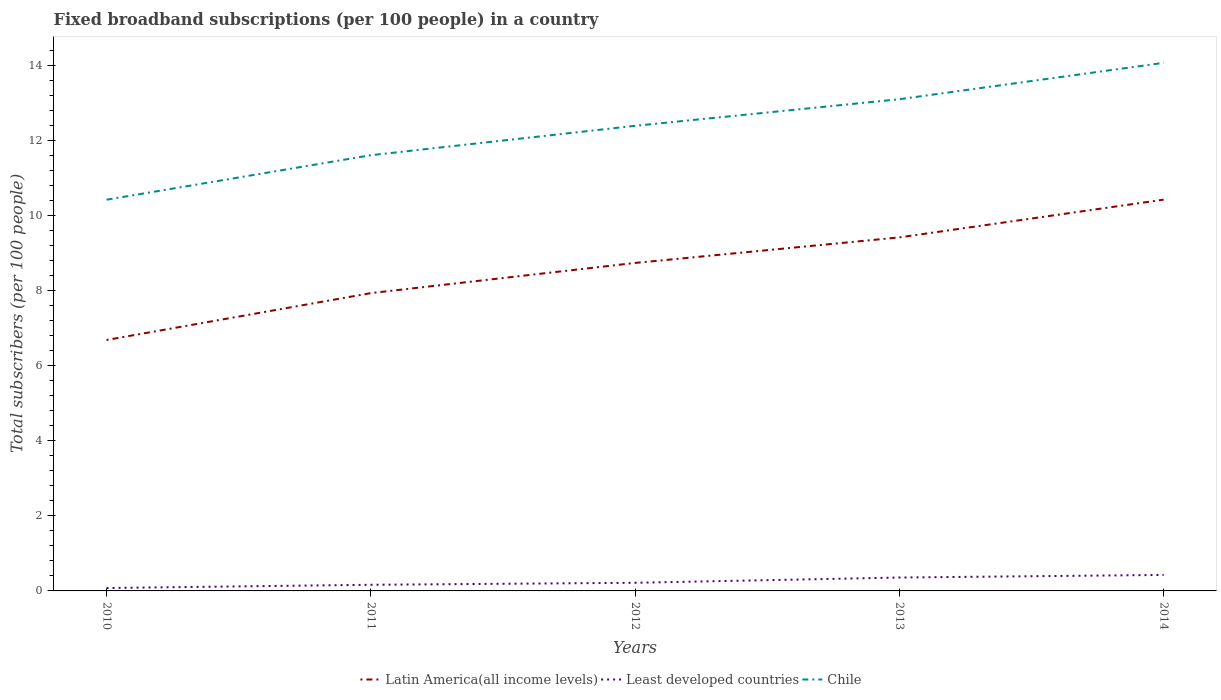Does the line corresponding to Least developed countries intersect with the line corresponding to Chile?
Your answer should be very brief. No. Is the number of lines equal to the number of legend labels?
Offer a terse response. Yes. Across all years, what is the maximum number of broadband subscriptions in Latin America(all income levels)?
Offer a very short reply. 6.69. In which year was the number of broadband subscriptions in Latin America(all income levels) maximum?
Give a very brief answer. 2010. What is the total number of broadband subscriptions in Latin America(all income levels) in the graph?
Keep it short and to the point. -1.49. What is the difference between the highest and the second highest number of broadband subscriptions in Chile?
Your response must be concise. 3.65. What is the difference between the highest and the lowest number of broadband subscriptions in Least developed countries?
Ensure brevity in your answer.  2. Is the number of broadband subscriptions in Latin America(all income levels) strictly greater than the number of broadband subscriptions in Least developed countries over the years?
Your answer should be very brief. No. How many years are there in the graph?
Provide a succinct answer. 5. Does the graph contain any zero values?
Offer a terse response. No. How many legend labels are there?
Make the answer very short. 3. What is the title of the graph?
Your answer should be compact. Fixed broadband subscriptions (per 100 people) in a country. What is the label or title of the X-axis?
Provide a succinct answer. Years. What is the label or title of the Y-axis?
Keep it short and to the point. Total subscribers (per 100 people). What is the Total subscribers (per 100 people) of Latin America(all income levels) in 2010?
Give a very brief answer. 6.69. What is the Total subscribers (per 100 people) of Least developed countries in 2010?
Ensure brevity in your answer.  0.08. What is the Total subscribers (per 100 people) of Chile in 2010?
Provide a succinct answer. 10.43. What is the Total subscribers (per 100 people) in Latin America(all income levels) in 2011?
Offer a terse response. 7.94. What is the Total subscribers (per 100 people) in Least developed countries in 2011?
Keep it short and to the point. 0.16. What is the Total subscribers (per 100 people) of Chile in 2011?
Your answer should be very brief. 11.62. What is the Total subscribers (per 100 people) in Latin America(all income levels) in 2012?
Your answer should be compact. 8.75. What is the Total subscribers (per 100 people) of Least developed countries in 2012?
Give a very brief answer. 0.22. What is the Total subscribers (per 100 people) of Chile in 2012?
Keep it short and to the point. 12.4. What is the Total subscribers (per 100 people) in Latin America(all income levels) in 2013?
Offer a very short reply. 9.43. What is the Total subscribers (per 100 people) of Least developed countries in 2013?
Your answer should be compact. 0.36. What is the Total subscribers (per 100 people) of Chile in 2013?
Ensure brevity in your answer.  13.11. What is the Total subscribers (per 100 people) in Latin America(all income levels) in 2014?
Offer a terse response. 10.43. What is the Total subscribers (per 100 people) of Least developed countries in 2014?
Your answer should be very brief. 0.43. What is the Total subscribers (per 100 people) of Chile in 2014?
Keep it short and to the point. 14.08. Across all years, what is the maximum Total subscribers (per 100 people) of Latin America(all income levels)?
Your answer should be very brief. 10.43. Across all years, what is the maximum Total subscribers (per 100 people) in Least developed countries?
Offer a very short reply. 0.43. Across all years, what is the maximum Total subscribers (per 100 people) of Chile?
Give a very brief answer. 14.08. Across all years, what is the minimum Total subscribers (per 100 people) of Latin America(all income levels)?
Keep it short and to the point. 6.69. Across all years, what is the minimum Total subscribers (per 100 people) in Least developed countries?
Your answer should be compact. 0.08. Across all years, what is the minimum Total subscribers (per 100 people) in Chile?
Offer a very short reply. 10.43. What is the total Total subscribers (per 100 people) in Latin America(all income levels) in the graph?
Provide a succinct answer. 43.24. What is the total Total subscribers (per 100 people) in Least developed countries in the graph?
Your answer should be very brief. 1.24. What is the total Total subscribers (per 100 people) in Chile in the graph?
Ensure brevity in your answer.  61.65. What is the difference between the Total subscribers (per 100 people) of Latin America(all income levels) in 2010 and that in 2011?
Provide a succinct answer. -1.25. What is the difference between the Total subscribers (per 100 people) in Least developed countries in 2010 and that in 2011?
Provide a succinct answer. -0.09. What is the difference between the Total subscribers (per 100 people) in Chile in 2010 and that in 2011?
Make the answer very short. -1.19. What is the difference between the Total subscribers (per 100 people) of Latin America(all income levels) in 2010 and that in 2012?
Offer a terse response. -2.06. What is the difference between the Total subscribers (per 100 people) of Least developed countries in 2010 and that in 2012?
Provide a succinct answer. -0.14. What is the difference between the Total subscribers (per 100 people) of Chile in 2010 and that in 2012?
Make the answer very short. -1.97. What is the difference between the Total subscribers (per 100 people) of Latin America(all income levels) in 2010 and that in 2013?
Your response must be concise. -2.74. What is the difference between the Total subscribers (per 100 people) in Least developed countries in 2010 and that in 2013?
Offer a terse response. -0.28. What is the difference between the Total subscribers (per 100 people) in Chile in 2010 and that in 2013?
Provide a succinct answer. -2.68. What is the difference between the Total subscribers (per 100 people) in Latin America(all income levels) in 2010 and that in 2014?
Make the answer very short. -3.74. What is the difference between the Total subscribers (per 100 people) of Least developed countries in 2010 and that in 2014?
Your answer should be very brief. -0.35. What is the difference between the Total subscribers (per 100 people) in Chile in 2010 and that in 2014?
Offer a very short reply. -3.65. What is the difference between the Total subscribers (per 100 people) of Latin America(all income levels) in 2011 and that in 2012?
Ensure brevity in your answer.  -0.81. What is the difference between the Total subscribers (per 100 people) in Least developed countries in 2011 and that in 2012?
Make the answer very short. -0.05. What is the difference between the Total subscribers (per 100 people) of Chile in 2011 and that in 2012?
Provide a succinct answer. -0.78. What is the difference between the Total subscribers (per 100 people) of Latin America(all income levels) in 2011 and that in 2013?
Make the answer very short. -1.49. What is the difference between the Total subscribers (per 100 people) of Least developed countries in 2011 and that in 2013?
Ensure brevity in your answer.  -0.19. What is the difference between the Total subscribers (per 100 people) of Chile in 2011 and that in 2013?
Offer a terse response. -1.49. What is the difference between the Total subscribers (per 100 people) of Latin America(all income levels) in 2011 and that in 2014?
Your response must be concise. -2.49. What is the difference between the Total subscribers (per 100 people) of Least developed countries in 2011 and that in 2014?
Provide a short and direct response. -0.26. What is the difference between the Total subscribers (per 100 people) in Chile in 2011 and that in 2014?
Offer a very short reply. -2.46. What is the difference between the Total subscribers (per 100 people) in Latin America(all income levels) in 2012 and that in 2013?
Ensure brevity in your answer.  -0.68. What is the difference between the Total subscribers (per 100 people) in Least developed countries in 2012 and that in 2013?
Provide a short and direct response. -0.14. What is the difference between the Total subscribers (per 100 people) in Chile in 2012 and that in 2013?
Offer a terse response. -0.71. What is the difference between the Total subscribers (per 100 people) in Latin America(all income levels) in 2012 and that in 2014?
Offer a very short reply. -1.69. What is the difference between the Total subscribers (per 100 people) of Least developed countries in 2012 and that in 2014?
Your answer should be very brief. -0.21. What is the difference between the Total subscribers (per 100 people) in Chile in 2012 and that in 2014?
Provide a short and direct response. -1.68. What is the difference between the Total subscribers (per 100 people) in Latin America(all income levels) in 2013 and that in 2014?
Offer a terse response. -1.01. What is the difference between the Total subscribers (per 100 people) in Least developed countries in 2013 and that in 2014?
Your answer should be compact. -0.07. What is the difference between the Total subscribers (per 100 people) of Chile in 2013 and that in 2014?
Provide a short and direct response. -0.97. What is the difference between the Total subscribers (per 100 people) of Latin America(all income levels) in 2010 and the Total subscribers (per 100 people) of Least developed countries in 2011?
Keep it short and to the point. 6.53. What is the difference between the Total subscribers (per 100 people) of Latin America(all income levels) in 2010 and the Total subscribers (per 100 people) of Chile in 2011?
Your answer should be very brief. -4.93. What is the difference between the Total subscribers (per 100 people) of Least developed countries in 2010 and the Total subscribers (per 100 people) of Chile in 2011?
Offer a terse response. -11.54. What is the difference between the Total subscribers (per 100 people) in Latin America(all income levels) in 2010 and the Total subscribers (per 100 people) in Least developed countries in 2012?
Provide a short and direct response. 6.48. What is the difference between the Total subscribers (per 100 people) in Latin America(all income levels) in 2010 and the Total subscribers (per 100 people) in Chile in 2012?
Ensure brevity in your answer.  -5.71. What is the difference between the Total subscribers (per 100 people) of Least developed countries in 2010 and the Total subscribers (per 100 people) of Chile in 2012?
Provide a succinct answer. -12.33. What is the difference between the Total subscribers (per 100 people) of Latin America(all income levels) in 2010 and the Total subscribers (per 100 people) of Least developed countries in 2013?
Offer a very short reply. 6.34. What is the difference between the Total subscribers (per 100 people) of Latin America(all income levels) in 2010 and the Total subscribers (per 100 people) of Chile in 2013?
Your answer should be very brief. -6.42. What is the difference between the Total subscribers (per 100 people) of Least developed countries in 2010 and the Total subscribers (per 100 people) of Chile in 2013?
Provide a succinct answer. -13.04. What is the difference between the Total subscribers (per 100 people) in Latin America(all income levels) in 2010 and the Total subscribers (per 100 people) in Least developed countries in 2014?
Your answer should be compact. 6.27. What is the difference between the Total subscribers (per 100 people) of Latin America(all income levels) in 2010 and the Total subscribers (per 100 people) of Chile in 2014?
Offer a very short reply. -7.39. What is the difference between the Total subscribers (per 100 people) in Least developed countries in 2010 and the Total subscribers (per 100 people) in Chile in 2014?
Give a very brief answer. -14.01. What is the difference between the Total subscribers (per 100 people) of Latin America(all income levels) in 2011 and the Total subscribers (per 100 people) of Least developed countries in 2012?
Offer a very short reply. 7.73. What is the difference between the Total subscribers (per 100 people) in Latin America(all income levels) in 2011 and the Total subscribers (per 100 people) in Chile in 2012?
Provide a short and direct response. -4.46. What is the difference between the Total subscribers (per 100 people) in Least developed countries in 2011 and the Total subscribers (per 100 people) in Chile in 2012?
Your response must be concise. -12.24. What is the difference between the Total subscribers (per 100 people) in Latin America(all income levels) in 2011 and the Total subscribers (per 100 people) in Least developed countries in 2013?
Your response must be concise. 7.59. What is the difference between the Total subscribers (per 100 people) in Latin America(all income levels) in 2011 and the Total subscribers (per 100 people) in Chile in 2013?
Provide a succinct answer. -5.17. What is the difference between the Total subscribers (per 100 people) of Least developed countries in 2011 and the Total subscribers (per 100 people) of Chile in 2013?
Your answer should be very brief. -12.95. What is the difference between the Total subscribers (per 100 people) in Latin America(all income levels) in 2011 and the Total subscribers (per 100 people) in Least developed countries in 2014?
Make the answer very short. 7.52. What is the difference between the Total subscribers (per 100 people) in Latin America(all income levels) in 2011 and the Total subscribers (per 100 people) in Chile in 2014?
Provide a short and direct response. -6.14. What is the difference between the Total subscribers (per 100 people) in Least developed countries in 2011 and the Total subscribers (per 100 people) in Chile in 2014?
Provide a succinct answer. -13.92. What is the difference between the Total subscribers (per 100 people) of Latin America(all income levels) in 2012 and the Total subscribers (per 100 people) of Least developed countries in 2013?
Provide a short and direct response. 8.39. What is the difference between the Total subscribers (per 100 people) in Latin America(all income levels) in 2012 and the Total subscribers (per 100 people) in Chile in 2013?
Offer a very short reply. -4.37. What is the difference between the Total subscribers (per 100 people) in Least developed countries in 2012 and the Total subscribers (per 100 people) in Chile in 2013?
Provide a succinct answer. -12.9. What is the difference between the Total subscribers (per 100 people) in Latin America(all income levels) in 2012 and the Total subscribers (per 100 people) in Least developed countries in 2014?
Give a very brief answer. 8.32. What is the difference between the Total subscribers (per 100 people) of Latin America(all income levels) in 2012 and the Total subscribers (per 100 people) of Chile in 2014?
Keep it short and to the point. -5.34. What is the difference between the Total subscribers (per 100 people) in Least developed countries in 2012 and the Total subscribers (per 100 people) in Chile in 2014?
Your response must be concise. -13.87. What is the difference between the Total subscribers (per 100 people) of Latin America(all income levels) in 2013 and the Total subscribers (per 100 people) of Least developed countries in 2014?
Your answer should be very brief. 9. What is the difference between the Total subscribers (per 100 people) in Latin America(all income levels) in 2013 and the Total subscribers (per 100 people) in Chile in 2014?
Offer a terse response. -4.66. What is the difference between the Total subscribers (per 100 people) of Least developed countries in 2013 and the Total subscribers (per 100 people) of Chile in 2014?
Make the answer very short. -13.73. What is the average Total subscribers (per 100 people) in Latin America(all income levels) per year?
Ensure brevity in your answer.  8.65. What is the average Total subscribers (per 100 people) of Least developed countries per year?
Your answer should be very brief. 0.25. What is the average Total subscribers (per 100 people) in Chile per year?
Offer a terse response. 12.33. In the year 2010, what is the difference between the Total subscribers (per 100 people) of Latin America(all income levels) and Total subscribers (per 100 people) of Least developed countries?
Keep it short and to the point. 6.61. In the year 2010, what is the difference between the Total subscribers (per 100 people) in Latin America(all income levels) and Total subscribers (per 100 people) in Chile?
Your answer should be very brief. -3.74. In the year 2010, what is the difference between the Total subscribers (per 100 people) of Least developed countries and Total subscribers (per 100 people) of Chile?
Offer a terse response. -10.36. In the year 2011, what is the difference between the Total subscribers (per 100 people) in Latin America(all income levels) and Total subscribers (per 100 people) in Least developed countries?
Make the answer very short. 7.78. In the year 2011, what is the difference between the Total subscribers (per 100 people) of Latin America(all income levels) and Total subscribers (per 100 people) of Chile?
Your answer should be compact. -3.68. In the year 2011, what is the difference between the Total subscribers (per 100 people) in Least developed countries and Total subscribers (per 100 people) in Chile?
Your response must be concise. -11.46. In the year 2012, what is the difference between the Total subscribers (per 100 people) of Latin America(all income levels) and Total subscribers (per 100 people) of Least developed countries?
Your answer should be very brief. 8.53. In the year 2012, what is the difference between the Total subscribers (per 100 people) in Latin America(all income levels) and Total subscribers (per 100 people) in Chile?
Provide a short and direct response. -3.66. In the year 2012, what is the difference between the Total subscribers (per 100 people) in Least developed countries and Total subscribers (per 100 people) in Chile?
Your answer should be very brief. -12.19. In the year 2013, what is the difference between the Total subscribers (per 100 people) of Latin America(all income levels) and Total subscribers (per 100 people) of Least developed countries?
Make the answer very short. 9.07. In the year 2013, what is the difference between the Total subscribers (per 100 people) in Latin America(all income levels) and Total subscribers (per 100 people) in Chile?
Your answer should be compact. -3.69. In the year 2013, what is the difference between the Total subscribers (per 100 people) of Least developed countries and Total subscribers (per 100 people) of Chile?
Offer a terse response. -12.76. In the year 2014, what is the difference between the Total subscribers (per 100 people) in Latin America(all income levels) and Total subscribers (per 100 people) in Least developed countries?
Provide a succinct answer. 10.01. In the year 2014, what is the difference between the Total subscribers (per 100 people) in Latin America(all income levels) and Total subscribers (per 100 people) in Chile?
Ensure brevity in your answer.  -3.65. In the year 2014, what is the difference between the Total subscribers (per 100 people) in Least developed countries and Total subscribers (per 100 people) in Chile?
Offer a terse response. -13.66. What is the ratio of the Total subscribers (per 100 people) of Latin America(all income levels) in 2010 to that in 2011?
Make the answer very short. 0.84. What is the ratio of the Total subscribers (per 100 people) in Least developed countries in 2010 to that in 2011?
Offer a very short reply. 0.47. What is the ratio of the Total subscribers (per 100 people) in Chile in 2010 to that in 2011?
Your answer should be compact. 0.9. What is the ratio of the Total subscribers (per 100 people) of Latin America(all income levels) in 2010 to that in 2012?
Keep it short and to the point. 0.77. What is the ratio of the Total subscribers (per 100 people) of Least developed countries in 2010 to that in 2012?
Your response must be concise. 0.36. What is the ratio of the Total subscribers (per 100 people) of Chile in 2010 to that in 2012?
Your answer should be very brief. 0.84. What is the ratio of the Total subscribers (per 100 people) of Latin America(all income levels) in 2010 to that in 2013?
Give a very brief answer. 0.71. What is the ratio of the Total subscribers (per 100 people) of Least developed countries in 2010 to that in 2013?
Your answer should be compact. 0.22. What is the ratio of the Total subscribers (per 100 people) in Chile in 2010 to that in 2013?
Offer a very short reply. 0.8. What is the ratio of the Total subscribers (per 100 people) of Latin America(all income levels) in 2010 to that in 2014?
Provide a succinct answer. 0.64. What is the ratio of the Total subscribers (per 100 people) of Least developed countries in 2010 to that in 2014?
Your answer should be very brief. 0.18. What is the ratio of the Total subscribers (per 100 people) of Chile in 2010 to that in 2014?
Provide a succinct answer. 0.74. What is the ratio of the Total subscribers (per 100 people) in Latin America(all income levels) in 2011 to that in 2012?
Your answer should be compact. 0.91. What is the ratio of the Total subscribers (per 100 people) of Least developed countries in 2011 to that in 2012?
Your answer should be very brief. 0.76. What is the ratio of the Total subscribers (per 100 people) of Chile in 2011 to that in 2012?
Ensure brevity in your answer.  0.94. What is the ratio of the Total subscribers (per 100 people) in Latin America(all income levels) in 2011 to that in 2013?
Offer a very short reply. 0.84. What is the ratio of the Total subscribers (per 100 people) in Least developed countries in 2011 to that in 2013?
Ensure brevity in your answer.  0.46. What is the ratio of the Total subscribers (per 100 people) of Chile in 2011 to that in 2013?
Provide a succinct answer. 0.89. What is the ratio of the Total subscribers (per 100 people) in Latin America(all income levels) in 2011 to that in 2014?
Keep it short and to the point. 0.76. What is the ratio of the Total subscribers (per 100 people) of Least developed countries in 2011 to that in 2014?
Make the answer very short. 0.38. What is the ratio of the Total subscribers (per 100 people) of Chile in 2011 to that in 2014?
Offer a terse response. 0.83. What is the ratio of the Total subscribers (per 100 people) in Latin America(all income levels) in 2012 to that in 2013?
Offer a terse response. 0.93. What is the ratio of the Total subscribers (per 100 people) in Least developed countries in 2012 to that in 2013?
Provide a short and direct response. 0.61. What is the ratio of the Total subscribers (per 100 people) in Chile in 2012 to that in 2013?
Give a very brief answer. 0.95. What is the ratio of the Total subscribers (per 100 people) of Latin America(all income levels) in 2012 to that in 2014?
Your answer should be compact. 0.84. What is the ratio of the Total subscribers (per 100 people) in Least developed countries in 2012 to that in 2014?
Your answer should be compact. 0.51. What is the ratio of the Total subscribers (per 100 people) of Chile in 2012 to that in 2014?
Your answer should be very brief. 0.88. What is the ratio of the Total subscribers (per 100 people) in Latin America(all income levels) in 2013 to that in 2014?
Give a very brief answer. 0.9. What is the ratio of the Total subscribers (per 100 people) of Least developed countries in 2013 to that in 2014?
Your response must be concise. 0.84. What is the ratio of the Total subscribers (per 100 people) of Chile in 2013 to that in 2014?
Your answer should be very brief. 0.93. What is the difference between the highest and the second highest Total subscribers (per 100 people) in Latin America(all income levels)?
Provide a short and direct response. 1.01. What is the difference between the highest and the second highest Total subscribers (per 100 people) of Least developed countries?
Your answer should be compact. 0.07. What is the difference between the highest and the second highest Total subscribers (per 100 people) in Chile?
Your response must be concise. 0.97. What is the difference between the highest and the lowest Total subscribers (per 100 people) of Latin America(all income levels)?
Offer a terse response. 3.74. What is the difference between the highest and the lowest Total subscribers (per 100 people) in Least developed countries?
Make the answer very short. 0.35. What is the difference between the highest and the lowest Total subscribers (per 100 people) in Chile?
Provide a succinct answer. 3.65. 